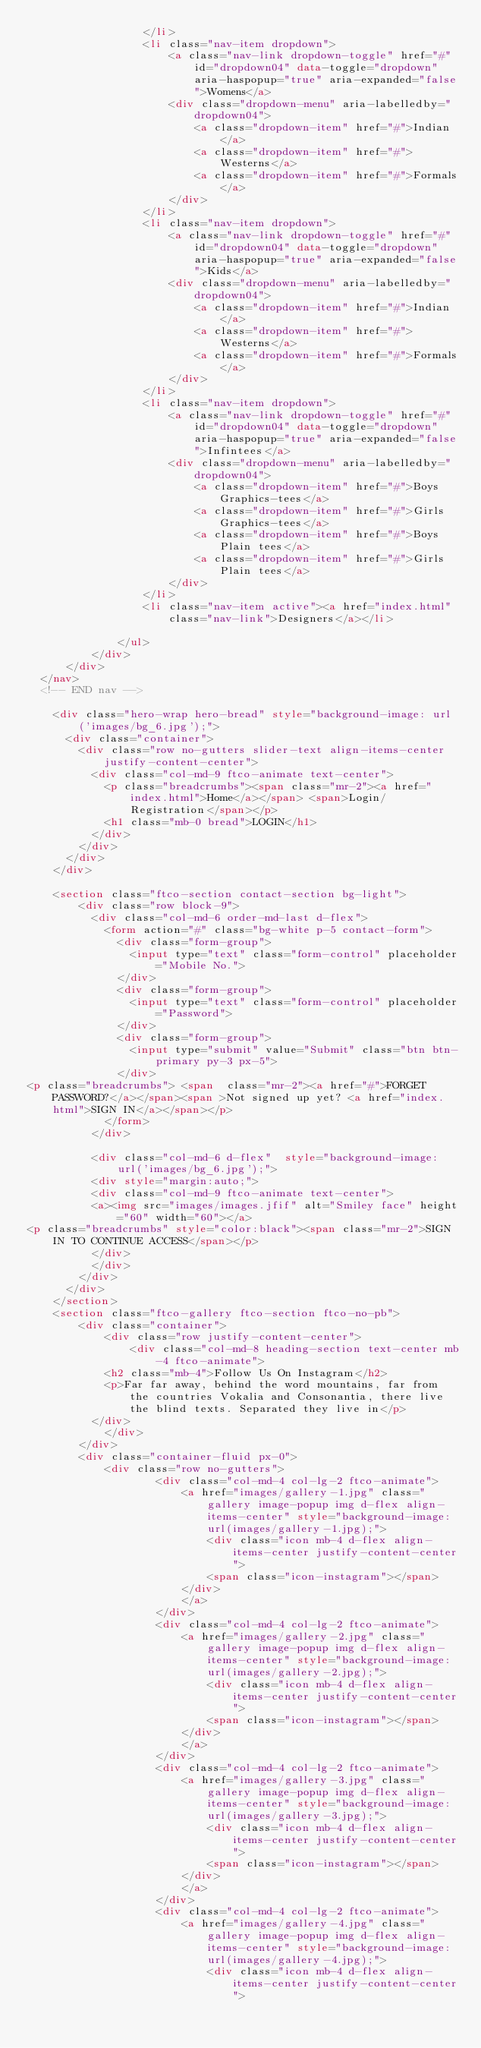<code> <loc_0><loc_0><loc_500><loc_500><_HTML_>                  </li>
                  <li class="nav-item dropdown">
                      <a class="nav-link dropdown-toggle" href="#" id="dropdown04" data-toggle="dropdown" aria-haspopup="true" aria-expanded="false">Womens</a>
                      <div class="dropdown-menu" aria-labelledby="dropdown04">
                          <a class="dropdown-item" href="#">Indian</a>
                          <a class="dropdown-item" href="#">Westerns</a>
                          <a class="dropdown-item" href="#">Formals</a>
                      </div>
                  </li>
                  <li class="nav-item dropdown">
                      <a class="nav-link dropdown-toggle" href="#" id="dropdown04" data-toggle="dropdown" aria-haspopup="true" aria-expanded="false">Kids</a>
                      <div class="dropdown-menu" aria-labelledby="dropdown04">
                          <a class="dropdown-item" href="#">Indian</a>
                          <a class="dropdown-item" href="#">Westerns</a>
                          <a class="dropdown-item" href="#">Formals</a>
                      </div>
                  </li>
                  <li class="nav-item dropdown">
                      <a class="nav-link dropdown-toggle" href="#" id="dropdown04" data-toggle="dropdown" aria-haspopup="true" aria-expanded="false">Infintees</a>
                      <div class="dropdown-menu" aria-labelledby="dropdown04">
                          <a class="dropdown-item" href="#">Boys Graphics-tees</a>
                          <a class="dropdown-item" href="#">Girls Graphics-tees</a>
                          <a class="dropdown-item" href="#">Boys Plain tees</a>
                          <a class="dropdown-item" href="#">Girls Plain tees</a>
                      </div>
                  </li>
                  <li class="nav-item active"><a href="index.html" class="nav-link">Designers</a></li>

              </ul>
          </div>
      </div>
  </nav>
  <!-- END nav -->

    <div class="hero-wrap hero-bread" style="background-image: url('images/bg_6.jpg');">
      <div class="container">
        <div class="row no-gutters slider-text align-items-center justify-content-center">
          <div class="col-md-9 ftco-animate text-center">
          	<p class="breadcrumbs"><span class="mr-2"><a href="index.html">Home</a></span> <span>Login/Registration</span></p>
            <h1 class="mb-0 bread">LOGIN</h1>
          </div>
        </div>
      </div>
    </div>

    <section class="ftco-section contact-section bg-light">
        <div class="row block-9">
          <div class="col-md-6 order-md-last d-flex">
            <form action="#" class="bg-white p-5 contact-form">
              <div class="form-group">
                <input type="text" class="form-control" placeholder="Mobile No.">
              </div>
              <div class="form-group">
                <input type="text" class="form-control" placeholder="Password">
              </div>
              <div class="form-group">
                <input type="submit" value="Submit" class="btn btn-primary py-3 px-5">
              </div>
<p class="breadcrumbs"> <span  class="mr-2"><a href="#">FORGET PASSWORD?</a></span><span >Not signed up yet? <a href="index.html">SIGN IN</a></span></p>
            </form>
          </div>

          <div class="col-md-6 d-flex"  style="background-image: url('images/bg_6.jpg');">
          <div style="margin:auto;">
          <div class="col-md-9 ftco-animate text-center">
          <a><img src="images/images.jfif" alt="Smiley face" height="60" width="60"></a>
<p class="breadcrumbs" style="color:black"><span class="mr-2">SIGN IN TO CONTINUE ACCESS</span></p>
          </div>
          </div>
        </div>
      </div>
    </section> 
    <section class="ftco-gallery ftco-section ftco-no-pb">
    	<div class="container">
    		<div class="row justify-content-center">
    			<div class="col-md-8 heading-section text-center mb-4 ftco-animate">
            <h2 class="mb-4">Follow Us On Instagram</h2>
            <p>Far far away, behind the word mountains, far from the countries Vokalia and Consonantia, there live the blind texts. Separated they live in</p>
          </div>
    		</div>
    	</div>
    	<div class="container-fluid px-0">
    		<div class="row no-gutters">
					<div class="col-md-4 col-lg-2 ftco-animate">
						<a href="images/gallery-1.jpg" class="gallery image-popup img d-flex align-items-center" style="background-image: url(images/gallery-1.jpg);">
							<div class="icon mb-4 d-flex align-items-center justify-content-center">
    						<span class="icon-instagram"></span>
    					</div>
						</a>
					</div>
					<div class="col-md-4 col-lg-2 ftco-animate">
						<a href="images/gallery-2.jpg" class="gallery image-popup img d-flex align-items-center" style="background-image: url(images/gallery-2.jpg);">
							<div class="icon mb-4 d-flex align-items-center justify-content-center">
    						<span class="icon-instagram"></span>
    					</div>
						</a>
					</div>
					<div class="col-md-4 col-lg-2 ftco-animate">
						<a href="images/gallery-3.jpg" class="gallery image-popup img d-flex align-items-center" style="background-image: url(images/gallery-3.jpg);">
							<div class="icon mb-4 d-flex align-items-center justify-content-center">
    						<span class="icon-instagram"></span>
    					</div>
						</a>
					</div>
					<div class="col-md-4 col-lg-2 ftco-animate">
						<a href="images/gallery-4.jpg" class="gallery image-popup img d-flex align-items-center" style="background-image: url(images/gallery-4.jpg);">
							<div class="icon mb-4 d-flex align-items-center justify-content-center"></code> 